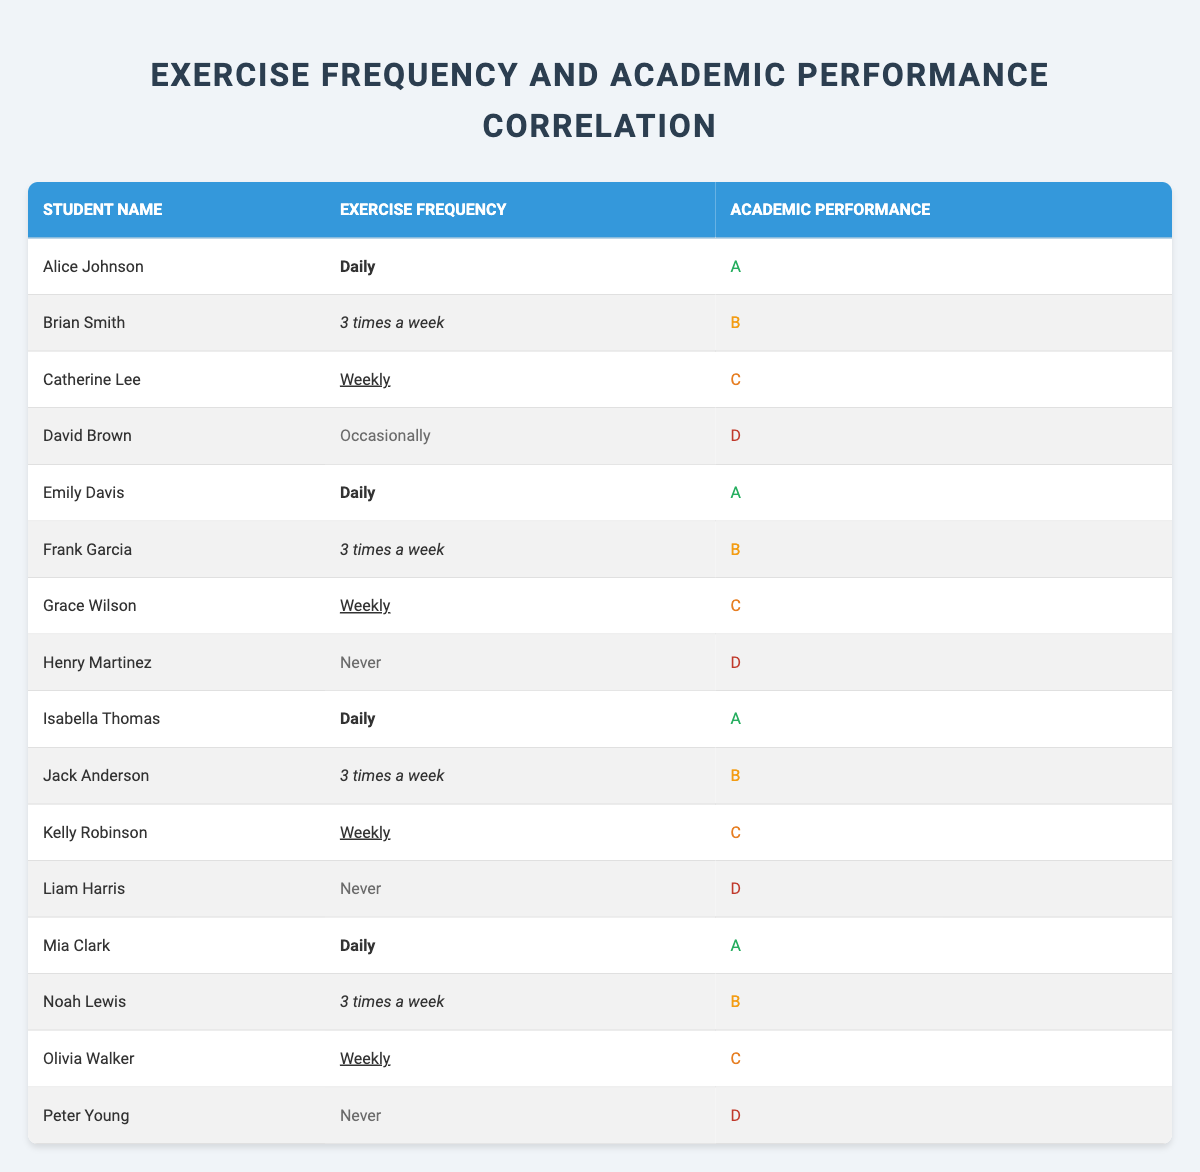What is the exercise frequency of Alice Johnson? Alice Johnson's exercise frequency is listed in the table under the "Exercise Frequency" column next to her name. According to the table, her exercise frequency is "Daily."
Answer: Daily How many students exercise occasionally? To find the number of students who exercise occasionally, we check the "Exercise Frequency" column and count how many have "Occasionally" listed. In the table, only one student (David Brown) has "Occasionally," resulting in a total of one student.
Answer: 1 What academic performance does a student who exercises daily achieve? By checking the "Academic Performance" column for students with "Daily" listed in the "Exercise Frequency" column, we can see multiple entries. The performance grades of those students (Alice Johnson, Emily Davis, Isabella Thomas, and Mia Clark) are all "A." Hence, students who exercise daily achieve an "A."
Answer: A Is there a student who exercises never and achieves an academic performance of "C"? We check the "Exercise Frequency" column for the entry "Never" and then look at the corresponding academic performance. The students listed as "Never" (Henry Martinez, Liam Harris, and Peter Young) all achieve grades of "D," so there is no student with never exercise and a "C" grade.
Answer: No What is the average academic performance of students who exercise three times a week? We first identify the students who exercise "3 times a week" which includes Brian Smith, Frank Garcia, Jack Anderson, and Noah Lewis with respective academic performances of B, B, B, and B. Since there are four students and all received a B, the average academic performance is B.
Answer: B How many students received an "A" grade? To find the number of students who received an "A," we look for "A" in the "Academic Performance" column. The students who received an "A" (Alice Johnson, Emily Davis, Isabella Thomas, and Mia Clark) total four students in the table.
Answer: 4 What is the difference in academic performance between the highest and lowest performing groups? The highest academic performance is represented by "A," and the lowest is "D." To calculate this difference in performance categories, converting these to a numerical scale (A=4, B=3, C=2, D=1), we get 4 (A) - 1 (D) = 3. Thus, the difference is 3 categories.
Answer: 3 Do all students who exercise weekly perform academically at the same level? Checking the "Exercise Frequency" of "Weekly" shows students with grades C (Catherine Lee, Grace Wilson, Kelly Robinson, and Olivia Walker). All four students achieve the same academic performance of "C," confirming they all perform at this level.
Answer: Yes How many students received a "D" while exercising occasionally or never? We check the "Academic Performance" for students labeled "Occasionally" (David Brown) and "Never" (Henry Martinez, Liam Harris, and Peter Young). The total number of students in this category is four, all of whom received a "D."
Answer: 4 